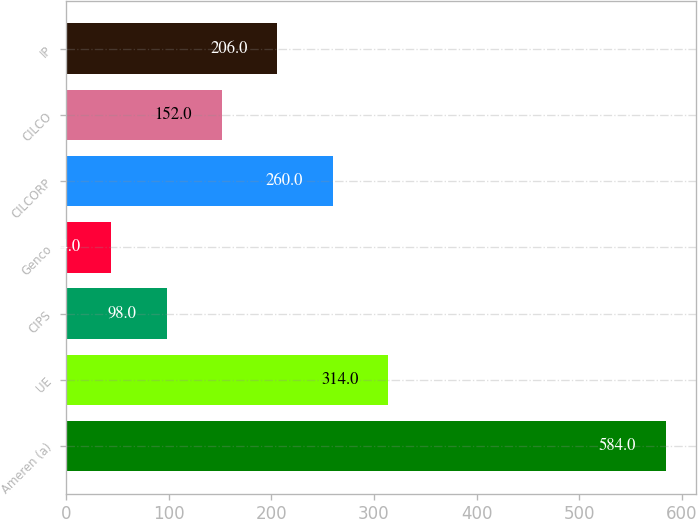Convert chart to OTSL. <chart><loc_0><loc_0><loc_500><loc_500><bar_chart><fcel>Ameren (a)<fcel>UE<fcel>CIPS<fcel>Genco<fcel>CILCORP<fcel>CILCO<fcel>IP<nl><fcel>584<fcel>314<fcel>98<fcel>44<fcel>260<fcel>152<fcel>206<nl></chart> 